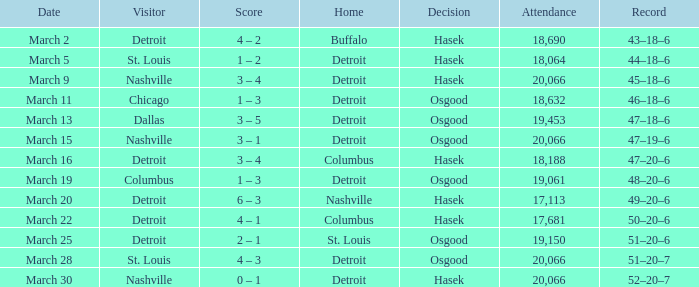What was the outcome of the red wings game when their record stood at 45-18-6? Hasek. 